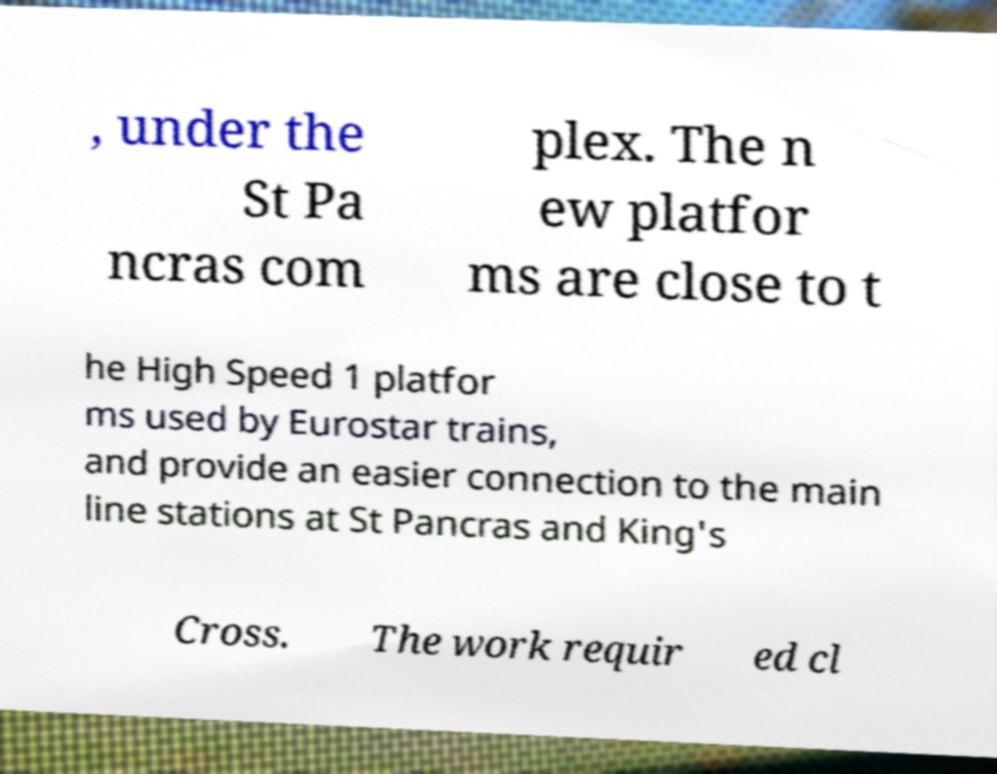There's text embedded in this image that I need extracted. Can you transcribe it verbatim? , under the St Pa ncras com plex. The n ew platfor ms are close to t he High Speed 1 platfor ms used by Eurostar trains, and provide an easier connection to the main line stations at St Pancras and King's Cross. The work requir ed cl 